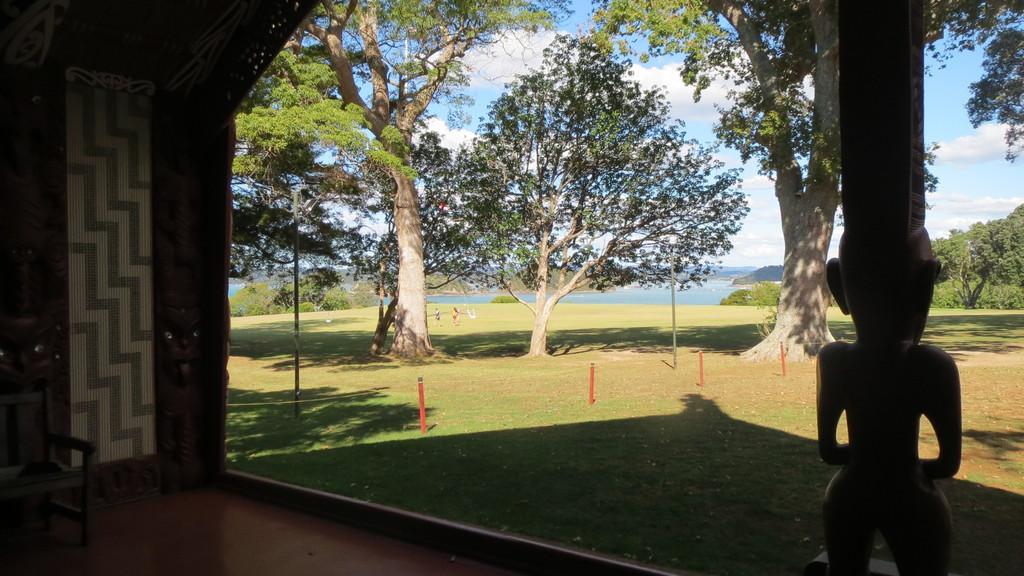How would you summarize this image in a sentence or two? This picture is clicked outside. On the left corner there is a chair placed on the ground. On the right corner there is a sculpture of a person. In the center we can see the green grass and the poles and we can see the trees. In the background we can see the plants, trees, sky and a water body. 